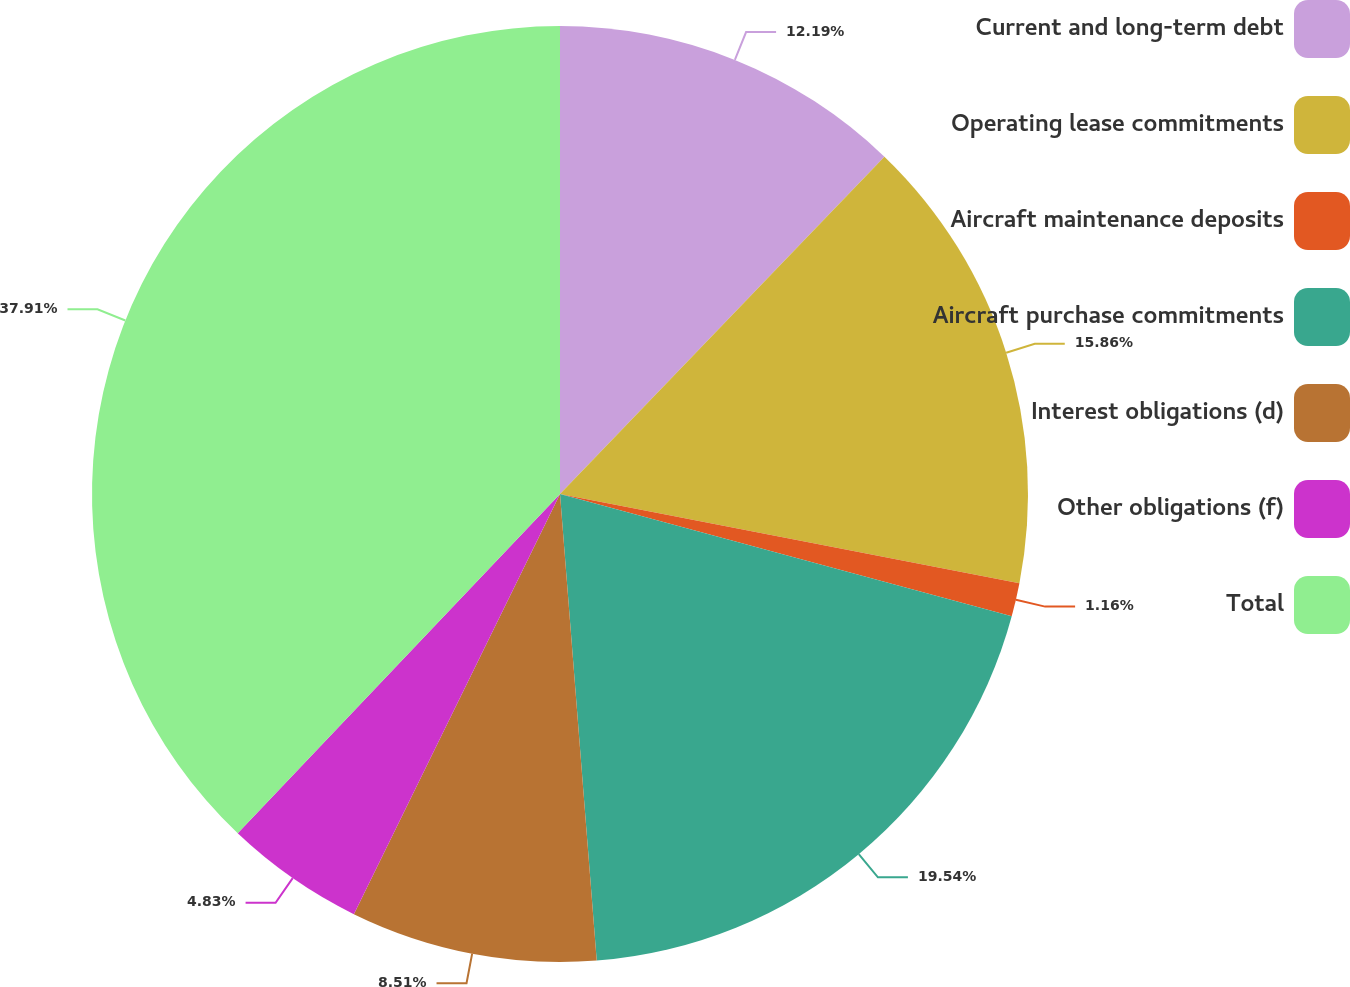Convert chart to OTSL. <chart><loc_0><loc_0><loc_500><loc_500><pie_chart><fcel>Current and long-term debt<fcel>Operating lease commitments<fcel>Aircraft maintenance deposits<fcel>Aircraft purchase commitments<fcel>Interest obligations (d)<fcel>Other obligations (f)<fcel>Total<nl><fcel>12.19%<fcel>15.86%<fcel>1.16%<fcel>19.54%<fcel>8.51%<fcel>4.83%<fcel>37.91%<nl></chart> 